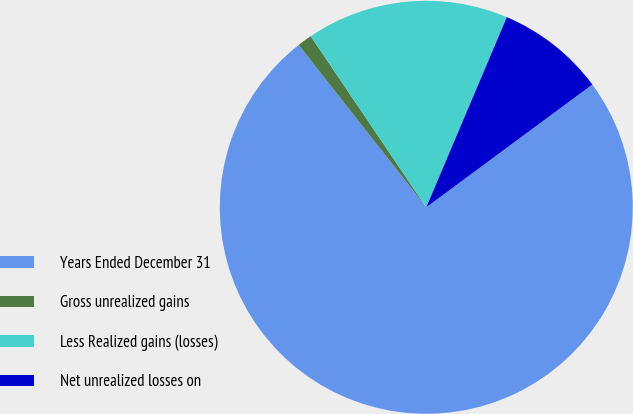<chart> <loc_0><loc_0><loc_500><loc_500><pie_chart><fcel>Years Ended December 31<fcel>Gross unrealized gains<fcel>Less Realized gains (losses)<fcel>Net unrealized losses on<nl><fcel>74.53%<fcel>1.15%<fcel>15.83%<fcel>8.49%<nl></chart> 